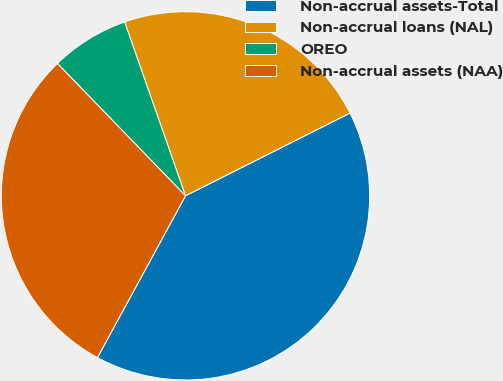Convert chart. <chart><loc_0><loc_0><loc_500><loc_500><pie_chart><fcel>Non-accrual assets-Total<fcel>Non-accrual loans (NAL)<fcel>OREO<fcel>Non-accrual assets (NAA)<nl><fcel>40.35%<fcel>22.95%<fcel>6.88%<fcel>29.83%<nl></chart> 